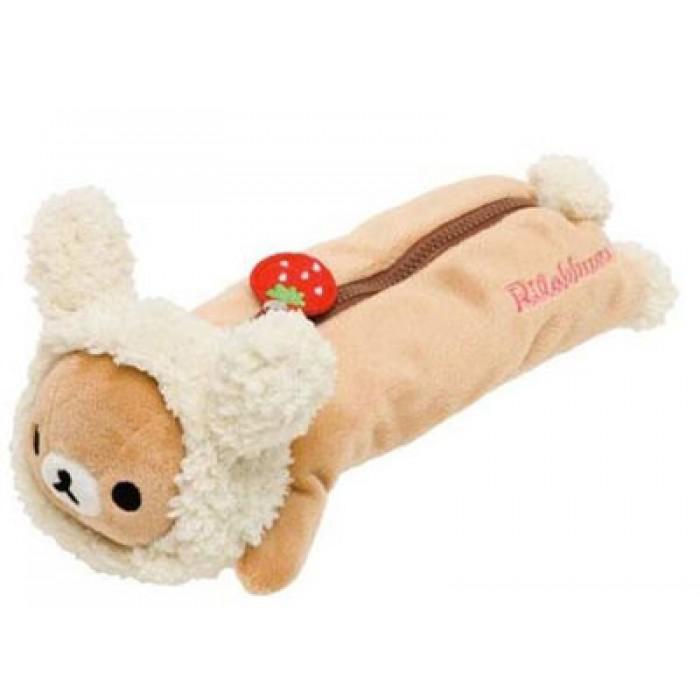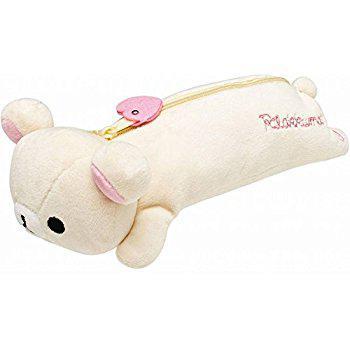The first image is the image on the left, the second image is the image on the right. Given the left and right images, does the statement "There is a plush teddy bear pencil case with a zipper facing to the left in both of the images." hold true? Answer yes or no. Yes. The first image is the image on the left, the second image is the image on the right. For the images shown, is this caption "a pencil pouch has a strawberry on the zipper" true? Answer yes or no. Yes. 